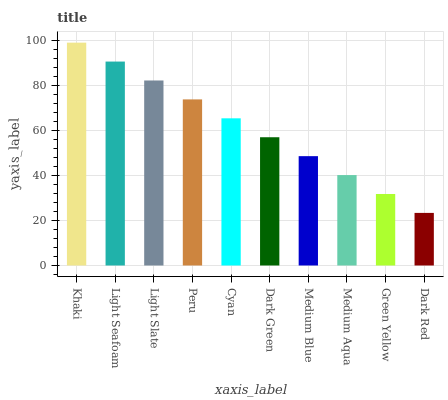Is Dark Red the minimum?
Answer yes or no. Yes. Is Khaki the maximum?
Answer yes or no. Yes. Is Light Seafoam the minimum?
Answer yes or no. No. Is Light Seafoam the maximum?
Answer yes or no. No. Is Khaki greater than Light Seafoam?
Answer yes or no. Yes. Is Light Seafoam less than Khaki?
Answer yes or no. Yes. Is Light Seafoam greater than Khaki?
Answer yes or no. No. Is Khaki less than Light Seafoam?
Answer yes or no. No. Is Cyan the high median?
Answer yes or no. Yes. Is Dark Green the low median?
Answer yes or no. Yes. Is Peru the high median?
Answer yes or no. No. Is Peru the low median?
Answer yes or no. No. 